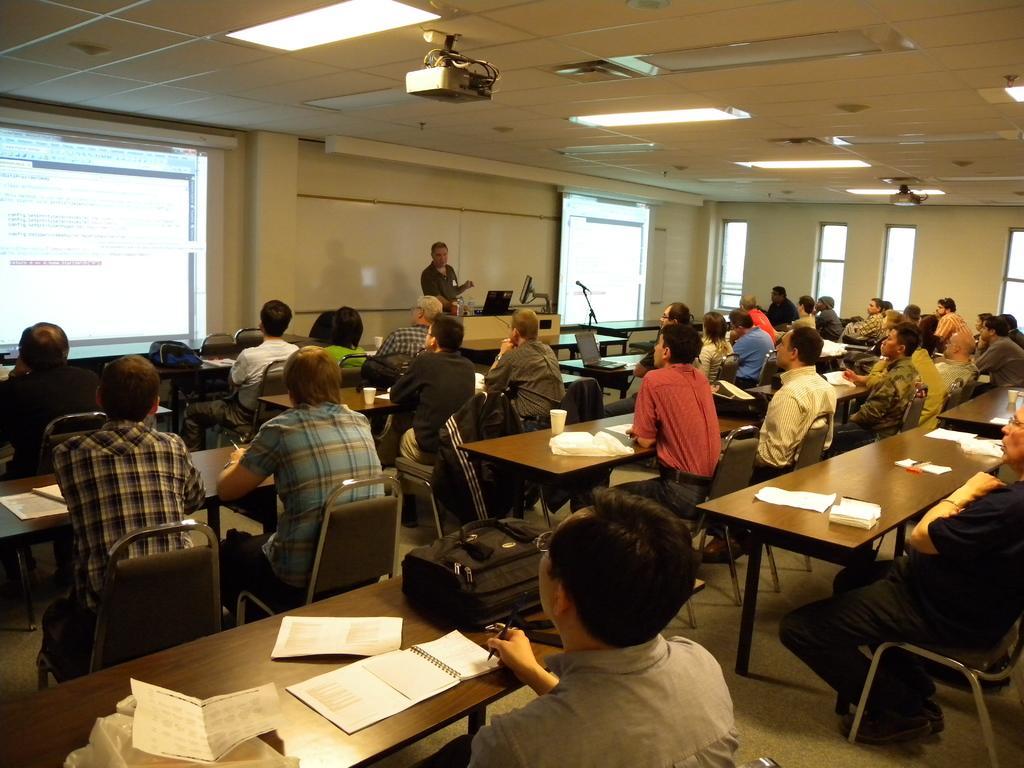Could you give a brief overview of what you see in this image? In this image I can see number of people are sitting on chairs and one man is standing. I can also see few tables and on these tables I can see books, papers, a bag, few glasses and few more stuffs. Here I can see two projectors and two screens. I can also see few monitors and a mic. 